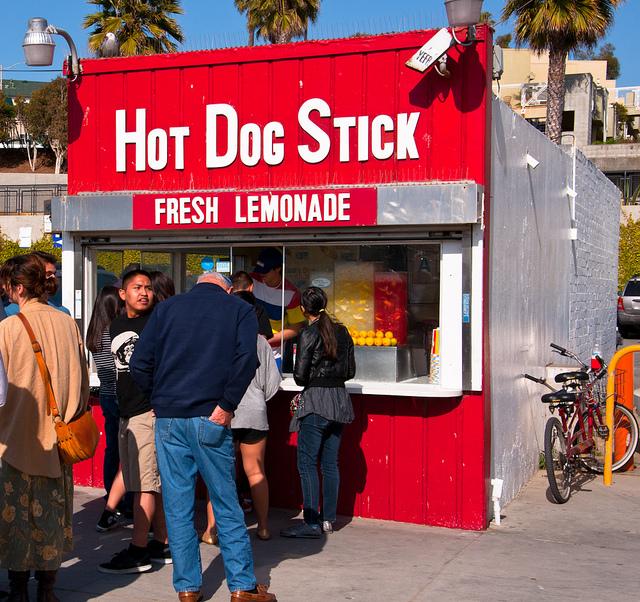How many lights are attached to the outside of the building?
Answer briefly. 2. What drink do they feature?
Answer briefly. Lemonade. What color stands out?
Be succinct. Red. Is the sign in English?
Concise answer only. Yes. What color is the trim at the bottom of the display?
Concise answer only. Red. Who owns the sausage stand?
Answer briefly. Man. Where is this security camera pointed?
Be succinct. At people. How many times does the word "dogs" appear in the image?
Write a very short answer. 0. 